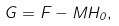<formula> <loc_0><loc_0><loc_500><loc_500>G = F - M H _ { 0 } ,</formula> 